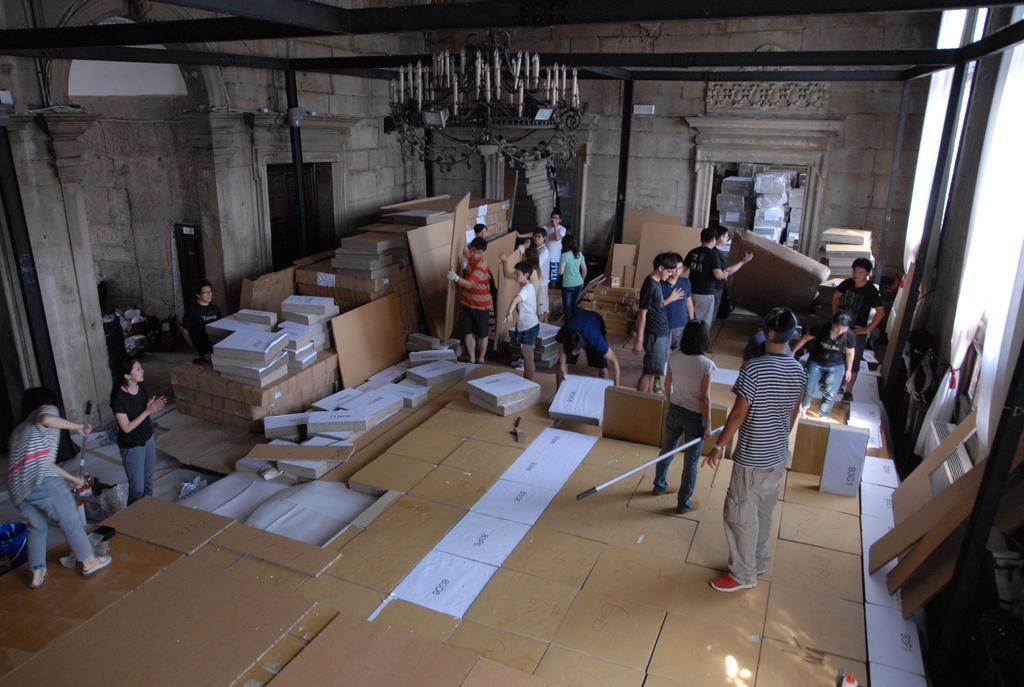Can you describe this image briefly? There are groups of people standing. Among them few people are holding the objects in their hands. I think these are the wooden boards. This looks like a chandelier with the candles, which is hanging to the roof. These are the iron bars. This looks like an arch. I can see the curtains hanging. This is the wall. 